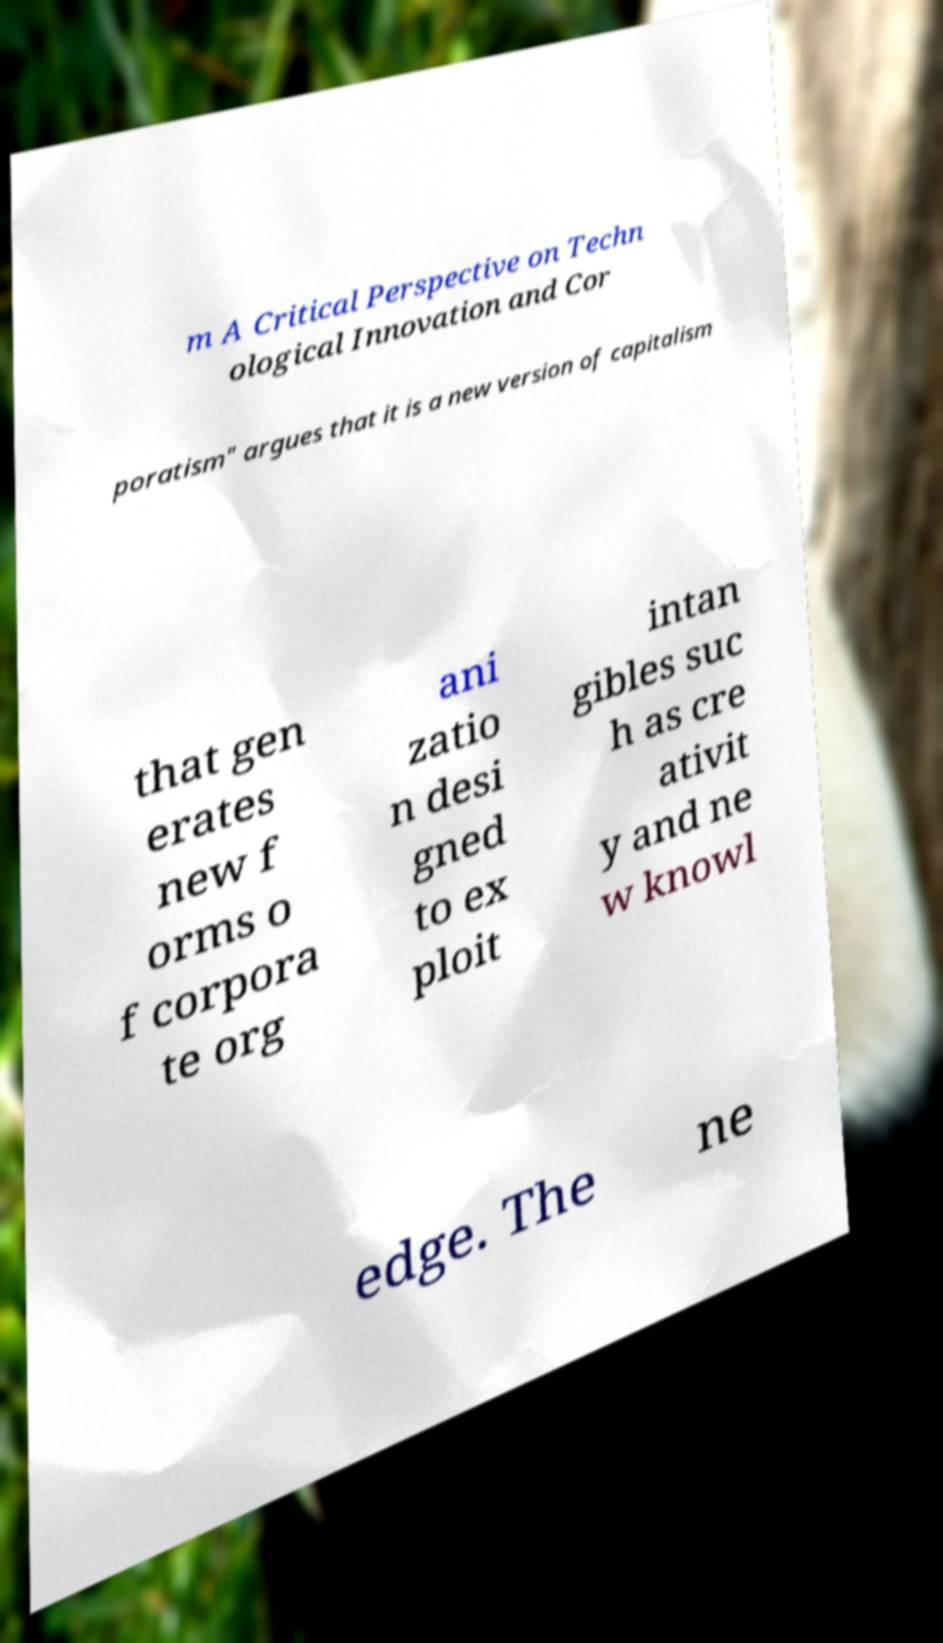Please read and relay the text visible in this image. What does it say? m A Critical Perspective on Techn ological Innovation and Cor poratism" argues that it is a new version of capitalism that gen erates new f orms o f corpora te org ani zatio n desi gned to ex ploit intan gibles suc h as cre ativit y and ne w knowl edge. The ne 